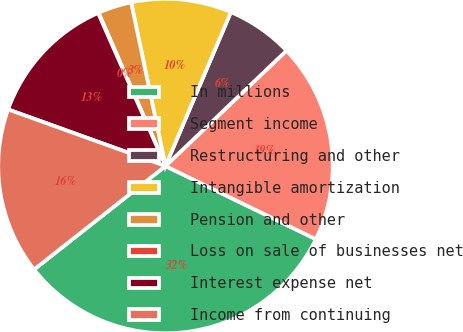Convert chart to OTSL. <chart><loc_0><loc_0><loc_500><loc_500><pie_chart><fcel>In millions<fcel>Segment income<fcel>Restructuring and other<fcel>Intangible amortization<fcel>Pension and other<fcel>Loss on sale of businesses net<fcel>Interest expense net<fcel>Income from continuing<nl><fcel>32.18%<fcel>19.33%<fcel>6.48%<fcel>9.69%<fcel>3.26%<fcel>0.05%<fcel>12.9%<fcel>16.11%<nl></chart> 